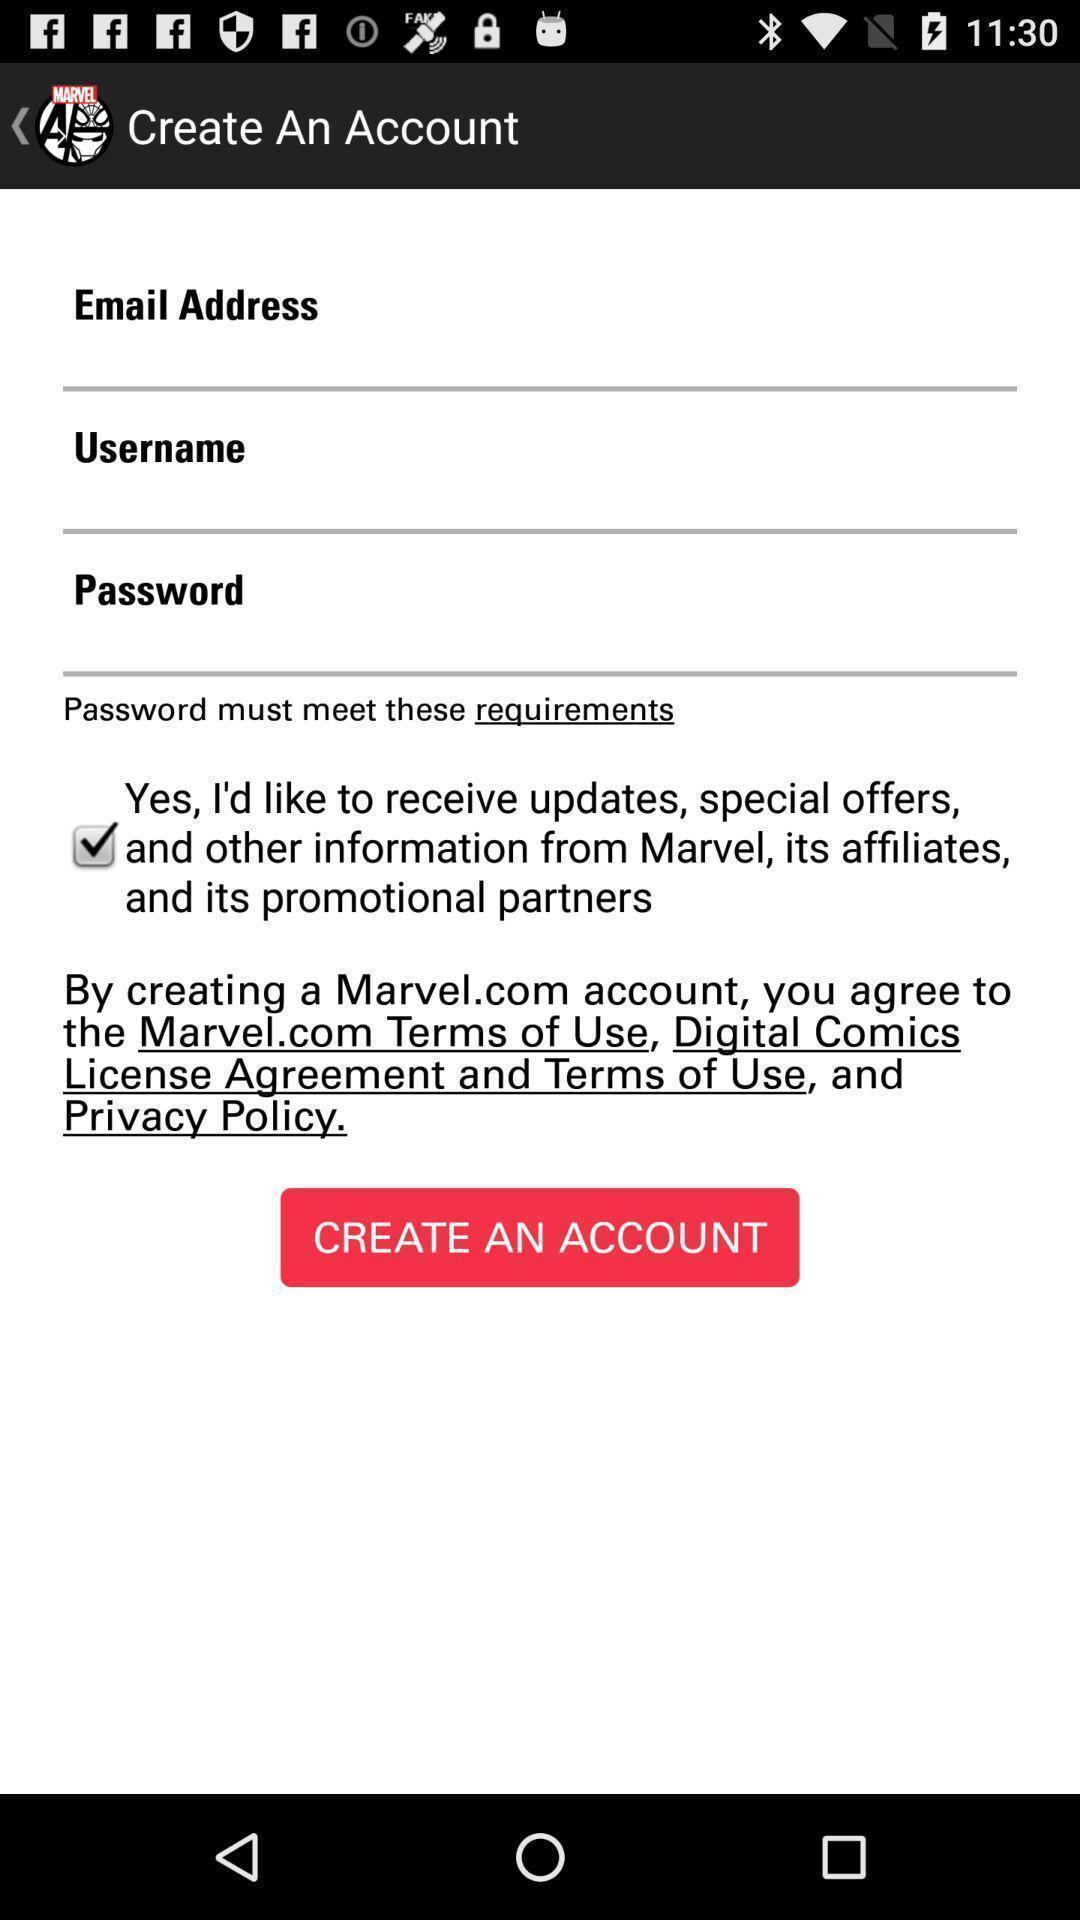Describe this image in words. Sign up page. 